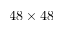<formula> <loc_0><loc_0><loc_500><loc_500>4 8 \times 4 8</formula> 